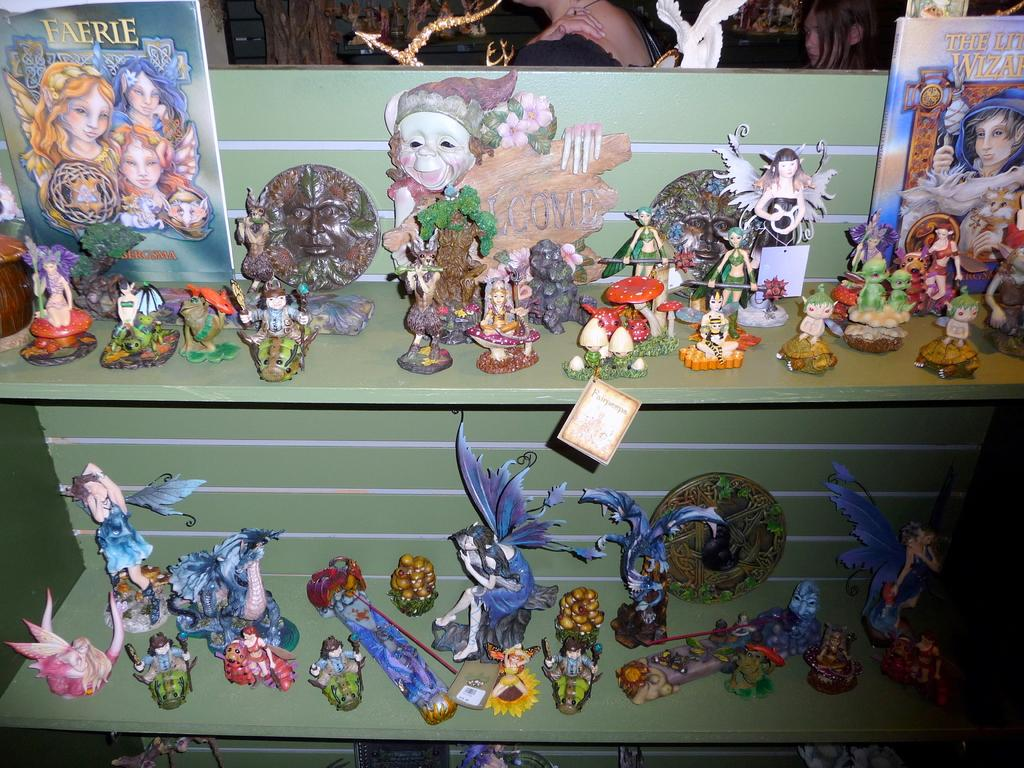How many people are present in the image? There are two people in the image. What can be seen on a surface in the image? There are objects on a surface in the image. What type of items are visible in the image? There are toys in the image. What is located on a table in the image? There are different objects on a table in the image. What is the person in the image writing on the table? There is no person writing on the table in the image. 